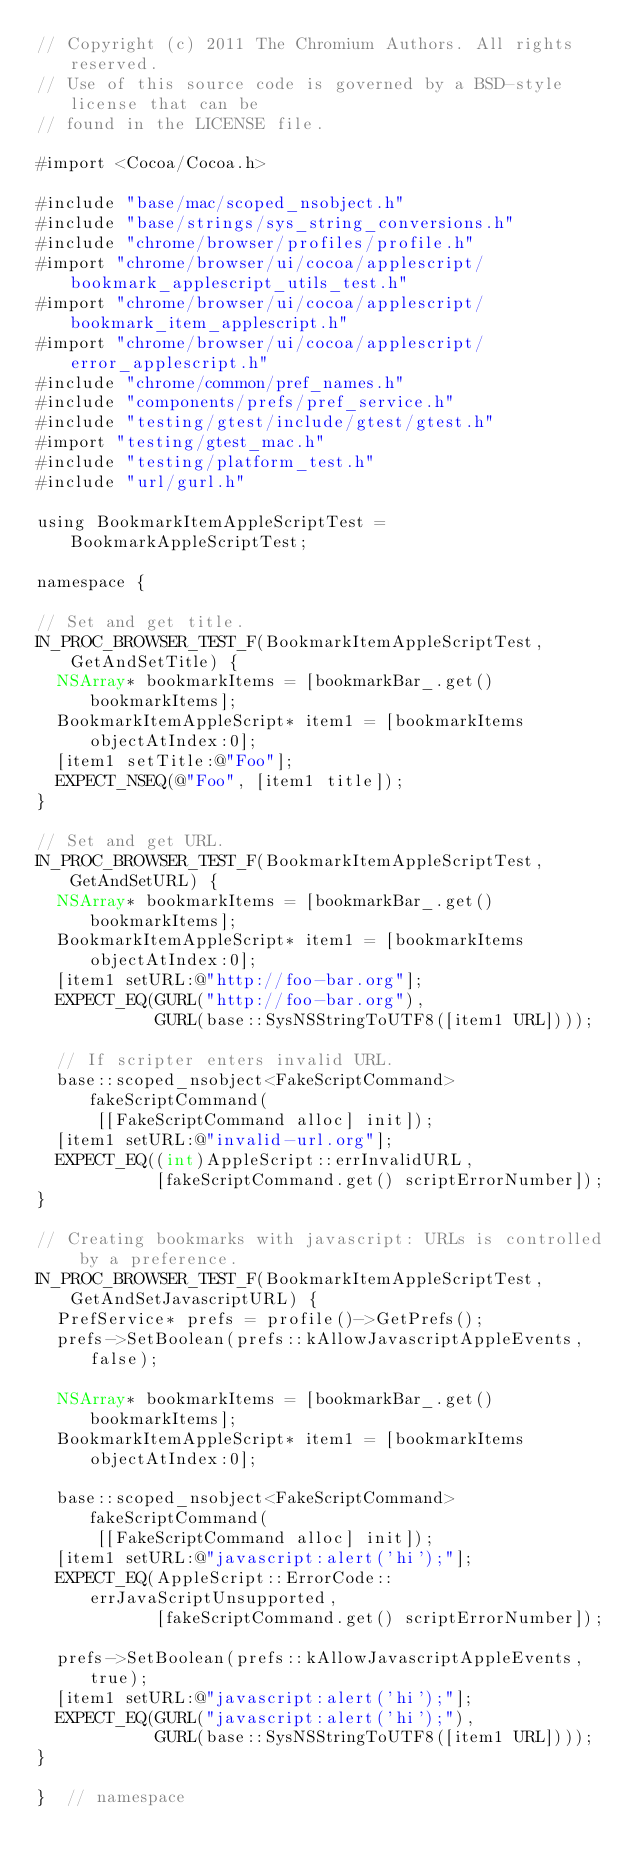<code> <loc_0><loc_0><loc_500><loc_500><_ObjectiveC_>// Copyright (c) 2011 The Chromium Authors. All rights reserved.
// Use of this source code is governed by a BSD-style license that can be
// found in the LICENSE file.

#import <Cocoa/Cocoa.h>

#include "base/mac/scoped_nsobject.h"
#include "base/strings/sys_string_conversions.h"
#include "chrome/browser/profiles/profile.h"
#import "chrome/browser/ui/cocoa/applescript/bookmark_applescript_utils_test.h"
#import "chrome/browser/ui/cocoa/applescript/bookmark_item_applescript.h"
#import "chrome/browser/ui/cocoa/applescript/error_applescript.h"
#include "chrome/common/pref_names.h"
#include "components/prefs/pref_service.h"
#include "testing/gtest/include/gtest/gtest.h"
#import "testing/gtest_mac.h"
#include "testing/platform_test.h"
#include "url/gurl.h"

using BookmarkItemAppleScriptTest = BookmarkAppleScriptTest;

namespace {

// Set and get title.
IN_PROC_BROWSER_TEST_F(BookmarkItemAppleScriptTest, GetAndSetTitle) {
  NSArray* bookmarkItems = [bookmarkBar_.get() bookmarkItems];
  BookmarkItemAppleScript* item1 = [bookmarkItems objectAtIndex:0];
  [item1 setTitle:@"Foo"];
  EXPECT_NSEQ(@"Foo", [item1 title]);
}

// Set and get URL.
IN_PROC_BROWSER_TEST_F(BookmarkItemAppleScriptTest, GetAndSetURL) {
  NSArray* bookmarkItems = [bookmarkBar_.get() bookmarkItems];
  BookmarkItemAppleScript* item1 = [bookmarkItems objectAtIndex:0];
  [item1 setURL:@"http://foo-bar.org"];
  EXPECT_EQ(GURL("http://foo-bar.org"),
            GURL(base::SysNSStringToUTF8([item1 URL])));

  // If scripter enters invalid URL.
  base::scoped_nsobject<FakeScriptCommand> fakeScriptCommand(
      [[FakeScriptCommand alloc] init]);
  [item1 setURL:@"invalid-url.org"];
  EXPECT_EQ((int)AppleScript::errInvalidURL,
            [fakeScriptCommand.get() scriptErrorNumber]);
}

// Creating bookmarks with javascript: URLs is controlled by a preference.
IN_PROC_BROWSER_TEST_F(BookmarkItemAppleScriptTest, GetAndSetJavascriptURL) {
  PrefService* prefs = profile()->GetPrefs();
  prefs->SetBoolean(prefs::kAllowJavascriptAppleEvents, false);

  NSArray* bookmarkItems = [bookmarkBar_.get() bookmarkItems];
  BookmarkItemAppleScript* item1 = [bookmarkItems objectAtIndex:0];

  base::scoped_nsobject<FakeScriptCommand> fakeScriptCommand(
      [[FakeScriptCommand alloc] init]);
  [item1 setURL:@"javascript:alert('hi');"];
  EXPECT_EQ(AppleScript::ErrorCode::errJavaScriptUnsupported,
            [fakeScriptCommand.get() scriptErrorNumber]);

  prefs->SetBoolean(prefs::kAllowJavascriptAppleEvents, true);
  [item1 setURL:@"javascript:alert('hi');"];
  EXPECT_EQ(GURL("javascript:alert('hi');"),
            GURL(base::SysNSStringToUTF8([item1 URL])));
}

}  // namespace
</code> 